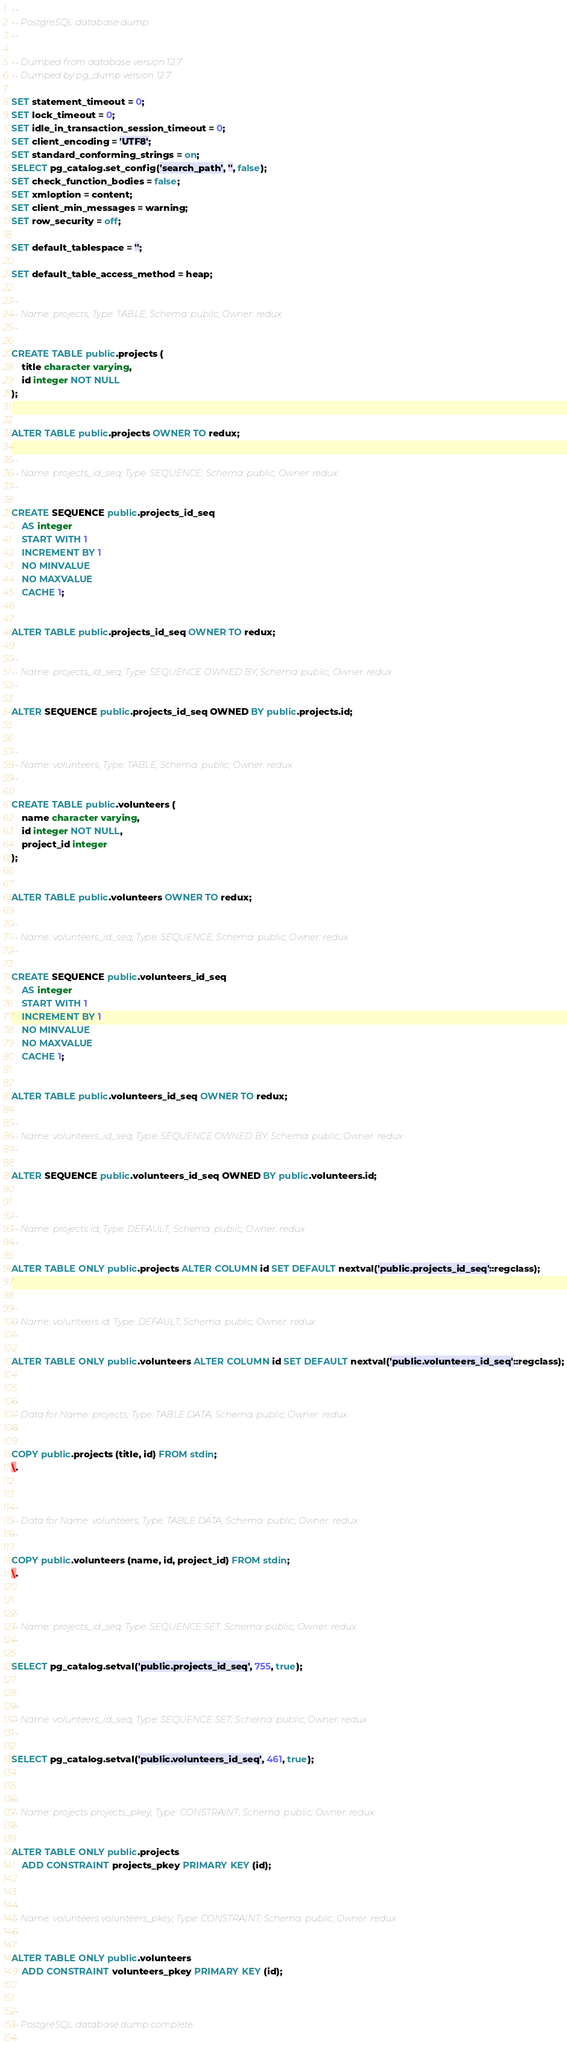<code> <loc_0><loc_0><loc_500><loc_500><_SQL_>--
-- PostgreSQL database dump
--

-- Dumped from database version 12.7
-- Dumped by pg_dump version 12.7

SET statement_timeout = 0;
SET lock_timeout = 0;
SET idle_in_transaction_session_timeout = 0;
SET client_encoding = 'UTF8';
SET standard_conforming_strings = on;
SELECT pg_catalog.set_config('search_path', '', false);
SET check_function_bodies = false;
SET xmloption = content;
SET client_min_messages = warning;
SET row_security = off;

SET default_tablespace = '';

SET default_table_access_method = heap;

--
-- Name: projects; Type: TABLE; Schema: public; Owner: redux
--

CREATE TABLE public.projects (
    title character varying,
    id integer NOT NULL
);


ALTER TABLE public.projects OWNER TO redux;

--
-- Name: projects_id_seq; Type: SEQUENCE; Schema: public; Owner: redux
--

CREATE SEQUENCE public.projects_id_seq
    AS integer
    START WITH 1
    INCREMENT BY 1
    NO MINVALUE
    NO MAXVALUE
    CACHE 1;


ALTER TABLE public.projects_id_seq OWNER TO redux;

--
-- Name: projects_id_seq; Type: SEQUENCE OWNED BY; Schema: public; Owner: redux
--

ALTER SEQUENCE public.projects_id_seq OWNED BY public.projects.id;


--
-- Name: volunteers; Type: TABLE; Schema: public; Owner: redux
--

CREATE TABLE public.volunteers (
    name character varying,
    id integer NOT NULL,
    project_id integer
);


ALTER TABLE public.volunteers OWNER TO redux;

--
-- Name: volunteers_id_seq; Type: SEQUENCE; Schema: public; Owner: redux
--

CREATE SEQUENCE public.volunteers_id_seq
    AS integer
    START WITH 1
    INCREMENT BY 1
    NO MINVALUE
    NO MAXVALUE
    CACHE 1;


ALTER TABLE public.volunteers_id_seq OWNER TO redux;

--
-- Name: volunteers_id_seq; Type: SEQUENCE OWNED BY; Schema: public; Owner: redux
--

ALTER SEQUENCE public.volunteers_id_seq OWNED BY public.volunteers.id;


--
-- Name: projects id; Type: DEFAULT; Schema: public; Owner: redux
--

ALTER TABLE ONLY public.projects ALTER COLUMN id SET DEFAULT nextval('public.projects_id_seq'::regclass);


--
-- Name: volunteers id; Type: DEFAULT; Schema: public; Owner: redux
--

ALTER TABLE ONLY public.volunteers ALTER COLUMN id SET DEFAULT nextval('public.volunteers_id_seq'::regclass);


--
-- Data for Name: projects; Type: TABLE DATA; Schema: public; Owner: redux
--

COPY public.projects (title, id) FROM stdin;
\.


--
-- Data for Name: volunteers; Type: TABLE DATA; Schema: public; Owner: redux
--

COPY public.volunteers (name, id, project_id) FROM stdin;
\.


--
-- Name: projects_id_seq; Type: SEQUENCE SET; Schema: public; Owner: redux
--

SELECT pg_catalog.setval('public.projects_id_seq', 755, true);


--
-- Name: volunteers_id_seq; Type: SEQUENCE SET; Schema: public; Owner: redux
--

SELECT pg_catalog.setval('public.volunteers_id_seq', 461, true);


--
-- Name: projects projects_pkey; Type: CONSTRAINT; Schema: public; Owner: redux
--

ALTER TABLE ONLY public.projects
    ADD CONSTRAINT projects_pkey PRIMARY KEY (id);


--
-- Name: volunteers volunteers_pkey; Type: CONSTRAINT; Schema: public; Owner: redux
--

ALTER TABLE ONLY public.volunteers
    ADD CONSTRAINT volunteers_pkey PRIMARY KEY (id);


--
-- PostgreSQL database dump complete
--

</code> 